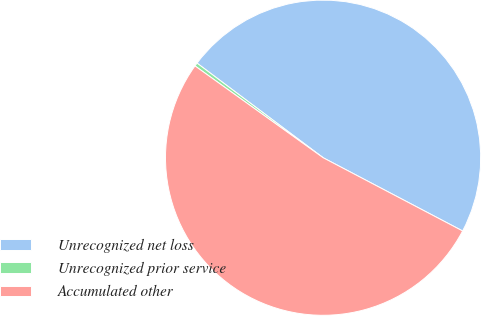<chart> <loc_0><loc_0><loc_500><loc_500><pie_chart><fcel>Unrecognized net loss<fcel>Unrecognized prior service<fcel>Accumulated other<nl><fcel>47.45%<fcel>0.35%<fcel>52.2%<nl></chart> 